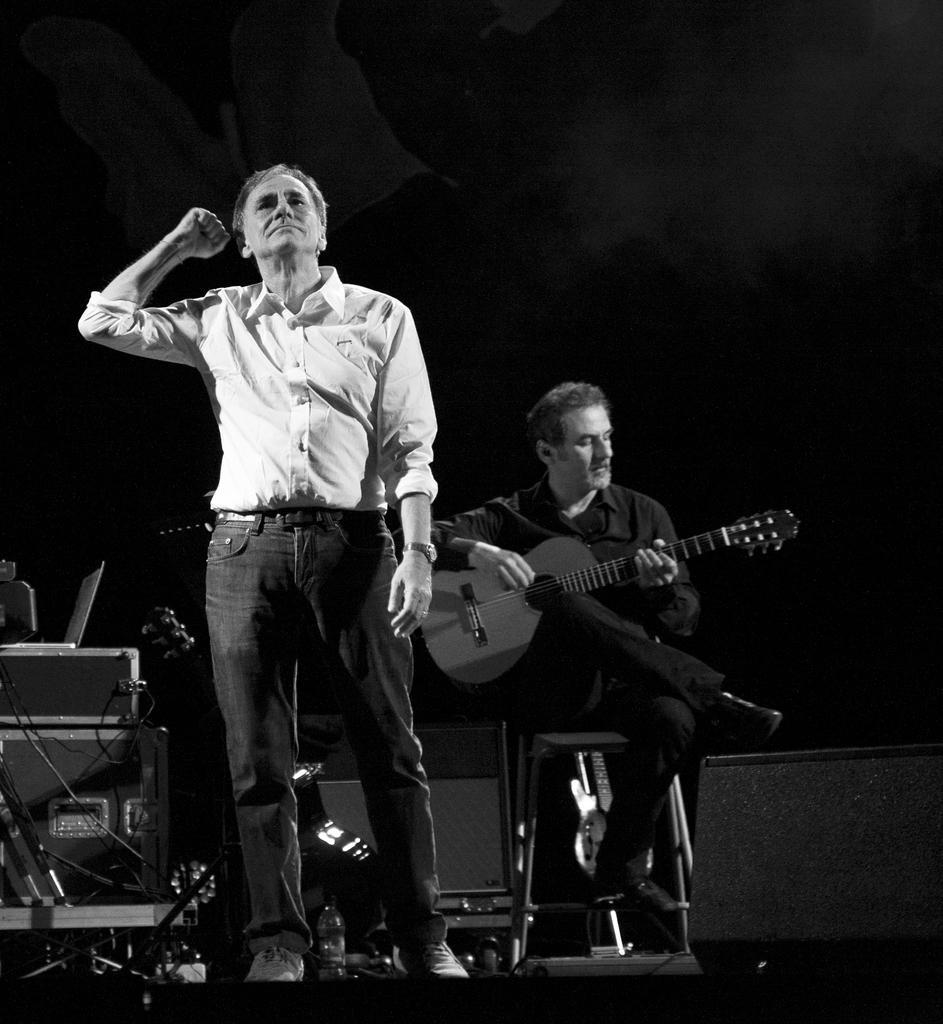Can you describe this image briefly? a person is standing wearing a white shirt. behind him a person is sitting on the chair and playing guitar. he is wearing black dress. at the back there is black background. 